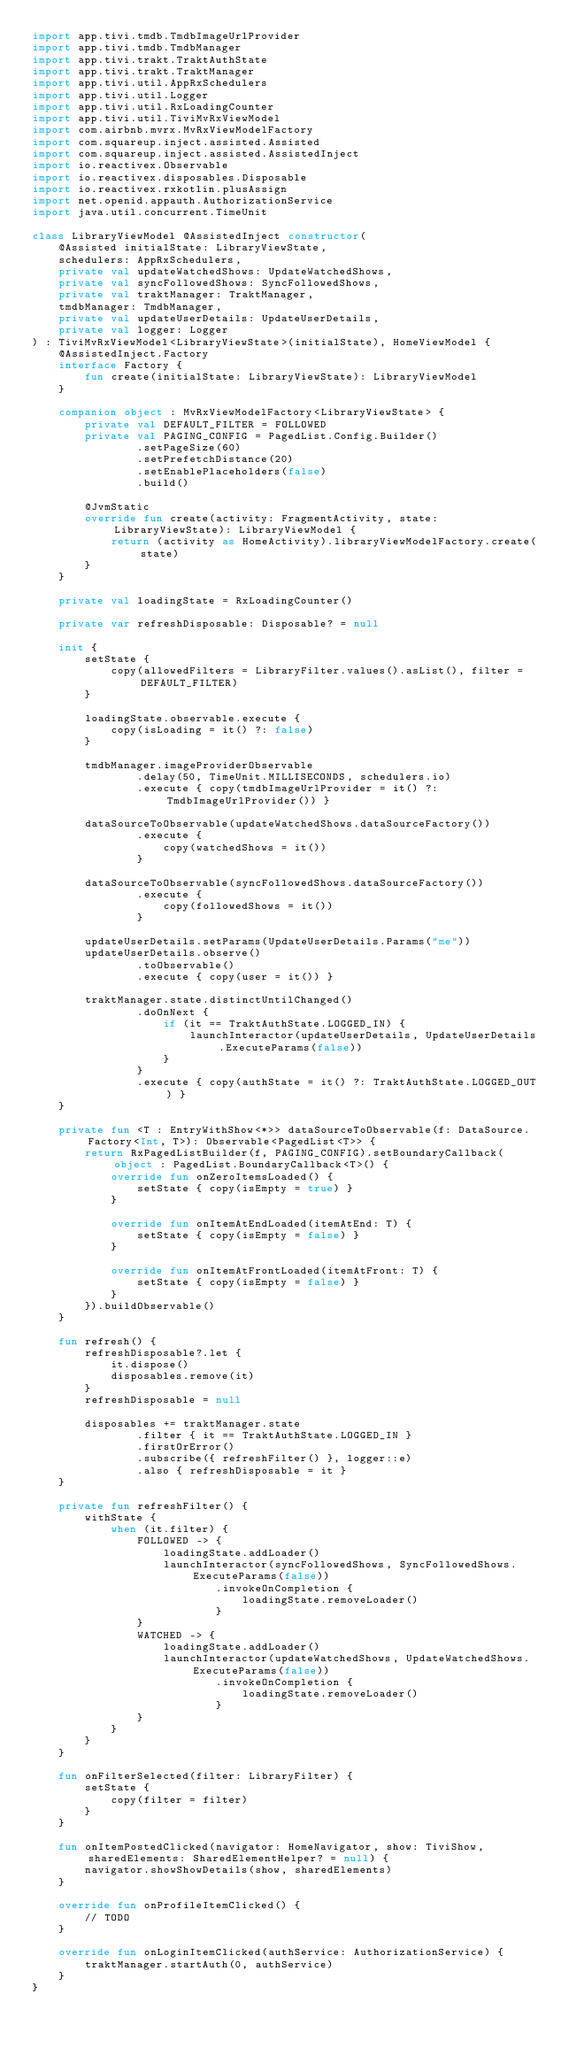<code> <loc_0><loc_0><loc_500><loc_500><_Kotlin_>import app.tivi.tmdb.TmdbImageUrlProvider
import app.tivi.tmdb.TmdbManager
import app.tivi.trakt.TraktAuthState
import app.tivi.trakt.TraktManager
import app.tivi.util.AppRxSchedulers
import app.tivi.util.Logger
import app.tivi.util.RxLoadingCounter
import app.tivi.util.TiviMvRxViewModel
import com.airbnb.mvrx.MvRxViewModelFactory
import com.squareup.inject.assisted.Assisted
import com.squareup.inject.assisted.AssistedInject
import io.reactivex.Observable
import io.reactivex.disposables.Disposable
import io.reactivex.rxkotlin.plusAssign
import net.openid.appauth.AuthorizationService
import java.util.concurrent.TimeUnit

class LibraryViewModel @AssistedInject constructor(
    @Assisted initialState: LibraryViewState,
    schedulers: AppRxSchedulers,
    private val updateWatchedShows: UpdateWatchedShows,
    private val syncFollowedShows: SyncFollowedShows,
    private val traktManager: TraktManager,
    tmdbManager: TmdbManager,
    private val updateUserDetails: UpdateUserDetails,
    private val logger: Logger
) : TiviMvRxViewModel<LibraryViewState>(initialState), HomeViewModel {
    @AssistedInject.Factory
    interface Factory {
        fun create(initialState: LibraryViewState): LibraryViewModel
    }

    companion object : MvRxViewModelFactory<LibraryViewState> {
        private val DEFAULT_FILTER = FOLLOWED
        private val PAGING_CONFIG = PagedList.Config.Builder()
                .setPageSize(60)
                .setPrefetchDistance(20)
                .setEnablePlaceholders(false)
                .build()

        @JvmStatic
        override fun create(activity: FragmentActivity, state: LibraryViewState): LibraryViewModel {
            return (activity as HomeActivity).libraryViewModelFactory.create(state)
        }
    }

    private val loadingState = RxLoadingCounter()

    private var refreshDisposable: Disposable? = null

    init {
        setState {
            copy(allowedFilters = LibraryFilter.values().asList(), filter = DEFAULT_FILTER)
        }

        loadingState.observable.execute {
            copy(isLoading = it() ?: false)
        }

        tmdbManager.imageProviderObservable
                .delay(50, TimeUnit.MILLISECONDS, schedulers.io)
                .execute { copy(tmdbImageUrlProvider = it() ?: TmdbImageUrlProvider()) }

        dataSourceToObservable(updateWatchedShows.dataSourceFactory())
                .execute {
                    copy(watchedShows = it())
                }

        dataSourceToObservable(syncFollowedShows.dataSourceFactory())
                .execute {
                    copy(followedShows = it())
                }

        updateUserDetails.setParams(UpdateUserDetails.Params("me"))
        updateUserDetails.observe()
                .toObservable()
                .execute { copy(user = it()) }

        traktManager.state.distinctUntilChanged()
                .doOnNext {
                    if (it == TraktAuthState.LOGGED_IN) {
                        launchInteractor(updateUserDetails, UpdateUserDetails.ExecuteParams(false))
                    }
                }
                .execute { copy(authState = it() ?: TraktAuthState.LOGGED_OUT) }
    }

    private fun <T : EntryWithShow<*>> dataSourceToObservable(f: DataSource.Factory<Int, T>): Observable<PagedList<T>> {
        return RxPagedListBuilder(f, PAGING_CONFIG).setBoundaryCallback(object : PagedList.BoundaryCallback<T>() {
            override fun onZeroItemsLoaded() {
                setState { copy(isEmpty = true) }
            }

            override fun onItemAtEndLoaded(itemAtEnd: T) {
                setState { copy(isEmpty = false) }
            }

            override fun onItemAtFrontLoaded(itemAtFront: T) {
                setState { copy(isEmpty = false) }
            }
        }).buildObservable()
    }

    fun refresh() {
        refreshDisposable?.let {
            it.dispose()
            disposables.remove(it)
        }
        refreshDisposable = null

        disposables += traktManager.state
                .filter { it == TraktAuthState.LOGGED_IN }
                .firstOrError()
                .subscribe({ refreshFilter() }, logger::e)
                .also { refreshDisposable = it }
    }

    private fun refreshFilter() {
        withState {
            when (it.filter) {
                FOLLOWED -> {
                    loadingState.addLoader()
                    launchInteractor(syncFollowedShows, SyncFollowedShows.ExecuteParams(false))
                            .invokeOnCompletion {
                                loadingState.removeLoader()
                            }
                }
                WATCHED -> {
                    loadingState.addLoader()
                    launchInteractor(updateWatchedShows, UpdateWatchedShows.ExecuteParams(false))
                            .invokeOnCompletion {
                                loadingState.removeLoader()
                            }
                }
            }
        }
    }

    fun onFilterSelected(filter: LibraryFilter) {
        setState {
            copy(filter = filter)
        }
    }

    fun onItemPostedClicked(navigator: HomeNavigator, show: TiviShow, sharedElements: SharedElementHelper? = null) {
        navigator.showShowDetails(show, sharedElements)
    }

    override fun onProfileItemClicked() {
        // TODO
    }

    override fun onLoginItemClicked(authService: AuthorizationService) {
        traktManager.startAuth(0, authService)
    }
}
</code> 